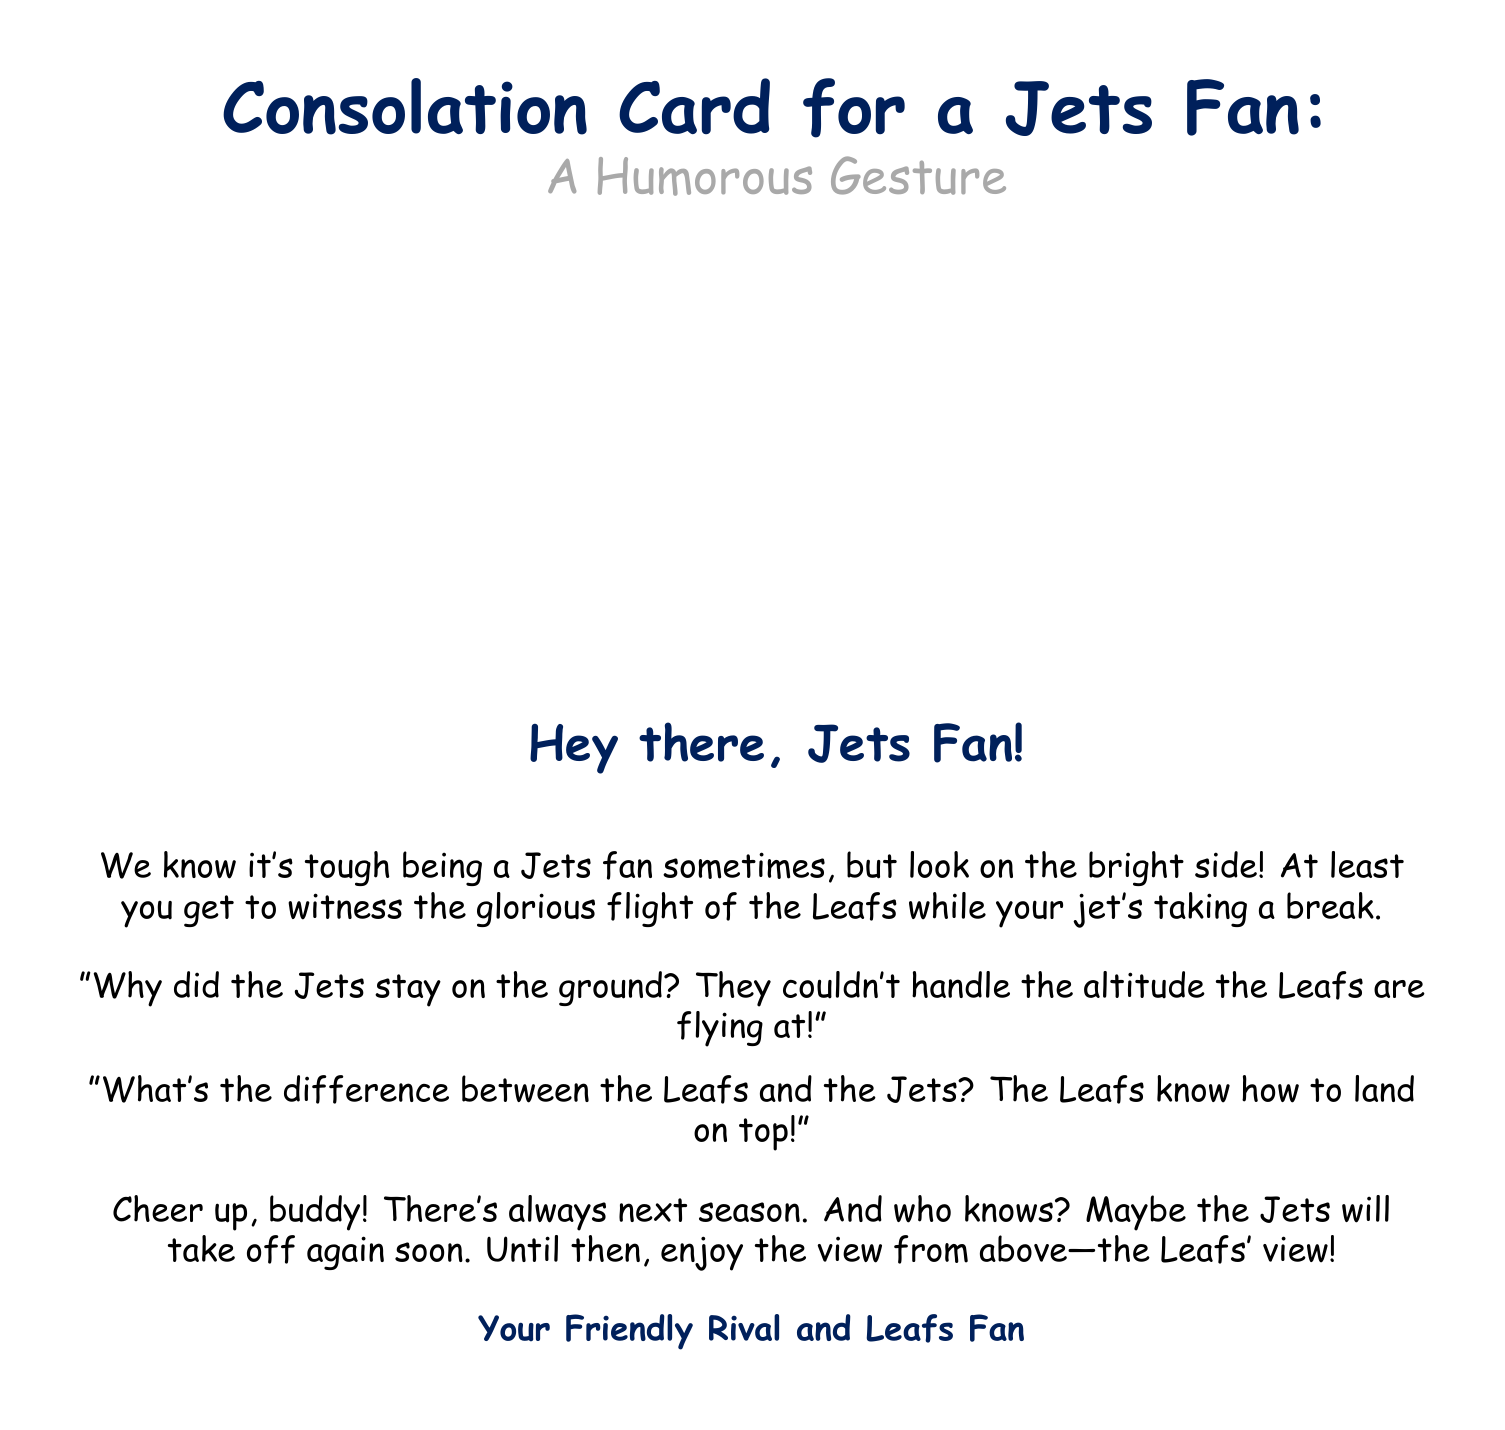What is the title of the card? The title is prominently displayed at the top of the document, and it is "Consolation Card for a Jets Fan: A Humorous Gesture".
Answer: Consolation Card for a Jets Fan: A Humorous Gesture What color is the Leafs flag in the drawing? The document describes a cartoon drawing featuring a grounded Winnipeg Jets jet with a Toronto Maple Leafs flag, which implies the flag's color is blue and white typical of the Leafs.
Answer: Blue and white What humorous phrase is included in the card? The card includes a humorous phrase regarding the Jets and their flight capabilities in contrast to the Leafs, which is "Why did the Jets stay on the ground? They couldn't handle the altitude the Leafs are flying at!"
Answer: Why did the Jets stay on the ground? They couldn't handle the altitude the Leafs are flying at! Who is the card addressed to? The greeting in the document directly addresses the recipient as "Jets Fan".
Answer: Jets Fan What is the primary theme of the card? The primary theme revolves around providing humor and consolation to a Jets fan while teasing about the performance of the Leafs.
Answer: Humor and consolation How many jokes are included in the card? There are two jokes presented in the card aimed at light-heartedly teasing the Jets fan.
Answer: Two What is the color of the text for the greeting? The greeting "Hey there, Jets Fan!" is printed in the color representative of the Leafs, which is a specific blue hue.
Answer: Leafs blue What is the final message to the recipient? The final message in the card encourages the Jets fan to look forward to next season with a positive outlook.
Answer: Cheer up, buddy! There's always next season 